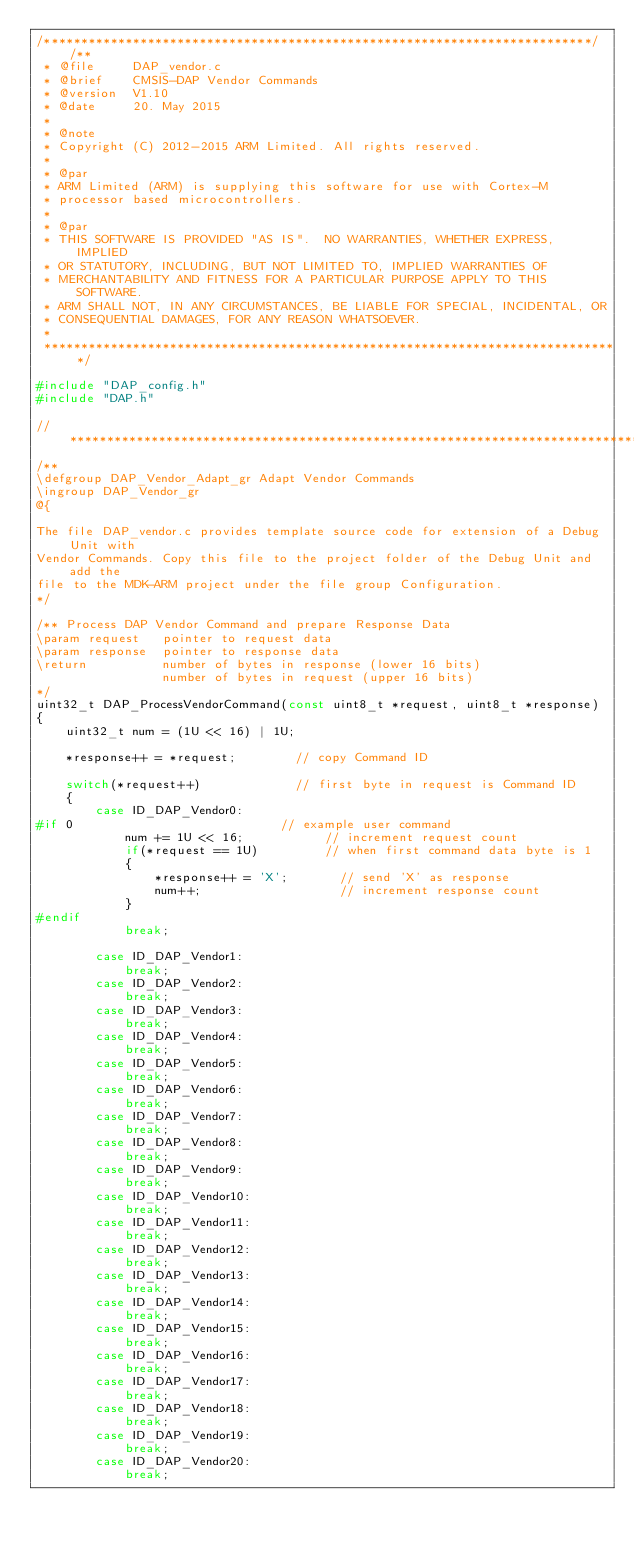Convert code to text. <code><loc_0><loc_0><loc_500><loc_500><_C_>/**************************************************************************//**
 * @file     DAP_vendor.c
 * @brief    CMSIS-DAP Vendor Commands
 * @version  V1.10
 * @date     20. May 2015
 *
 * @note
 * Copyright (C) 2012-2015 ARM Limited. All rights reserved.
 *
 * @par
 * ARM Limited (ARM) is supplying this software for use with Cortex-M
 * processor based microcontrollers.
 *
 * @par
 * THIS SOFTWARE IS PROVIDED "AS IS".  NO WARRANTIES, WHETHER EXPRESS, IMPLIED
 * OR STATUTORY, INCLUDING, BUT NOT LIMITED TO, IMPLIED WARRANTIES OF
 * MERCHANTABILITY AND FITNESS FOR A PARTICULAR PURPOSE APPLY TO THIS SOFTWARE.
 * ARM SHALL NOT, IN ANY CIRCUMSTANCES, BE LIABLE FOR SPECIAL, INCIDENTAL, OR
 * CONSEQUENTIAL DAMAGES, FOR ANY REASON WHATSOEVER.
 *
 ******************************************************************************/

#include "DAP_config.h"
#include "DAP.h"

//**************************************************************************************************
/**
\defgroup DAP_Vendor_Adapt_gr Adapt Vendor Commands
\ingroup DAP_Vendor_gr
@{

The file DAP_vendor.c provides template source code for extension of a Debug Unit with
Vendor Commands. Copy this file to the project folder of the Debug Unit and add the
file to the MDK-ARM project under the file group Configuration.
*/

/** Process DAP Vendor Command and prepare Response Data
\param request   pointer to request data
\param response  pointer to response data
\return          number of bytes in response (lower 16 bits)
                 number of bytes in request (upper 16 bits)
*/
uint32_t DAP_ProcessVendorCommand(const uint8_t *request, uint8_t *response)
{
    uint32_t num = (1U << 16) | 1U;

    *response++ = *request;        // copy Command ID

    switch(*request++)             // first byte in request is Command ID
    {
        case ID_DAP_Vendor0:
#if 0                            // example user command
            num += 1U << 16;           // increment request count
            if(*request == 1U)         // when first command data byte is 1
            {
                *response++ = 'X';       // send 'X' as response
                num++;                   // increment response count
            }
#endif
            break;

        case ID_DAP_Vendor1:
            break;
        case ID_DAP_Vendor2:
            break;
        case ID_DAP_Vendor3:
            break;
        case ID_DAP_Vendor4:
            break;
        case ID_DAP_Vendor5:
            break;
        case ID_DAP_Vendor6:
            break;
        case ID_DAP_Vendor7:
            break;
        case ID_DAP_Vendor8:
            break;
        case ID_DAP_Vendor9:
            break;
        case ID_DAP_Vendor10:
            break;
        case ID_DAP_Vendor11:
            break;
        case ID_DAP_Vendor12:
            break;
        case ID_DAP_Vendor13:
            break;
        case ID_DAP_Vendor14:
            break;
        case ID_DAP_Vendor15:
            break;
        case ID_DAP_Vendor16:
            break;
        case ID_DAP_Vendor17:
            break;
        case ID_DAP_Vendor18:
            break;
        case ID_DAP_Vendor19:
            break;
        case ID_DAP_Vendor20:
            break;</code> 